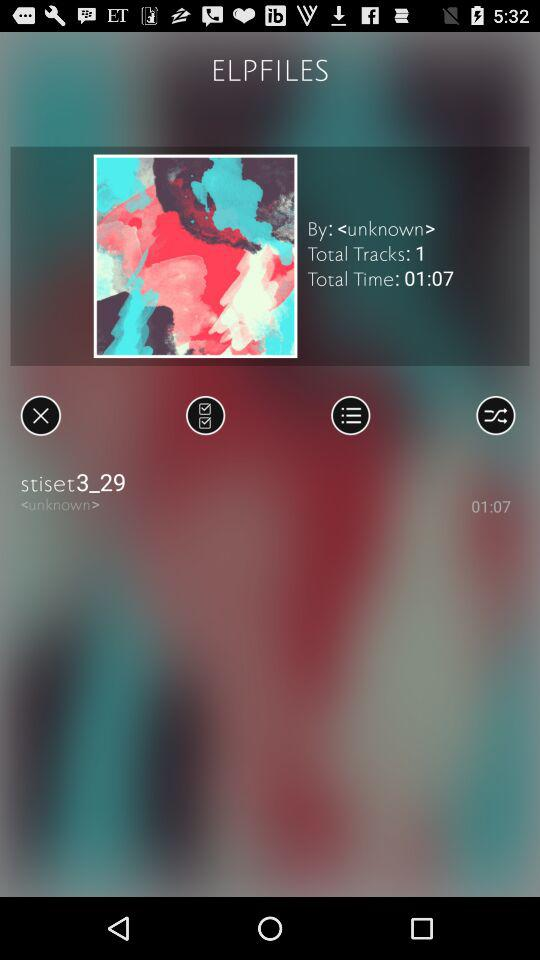What's the duration of the track "stiset3_29"? The duration is 1 minute 7 seconds. 